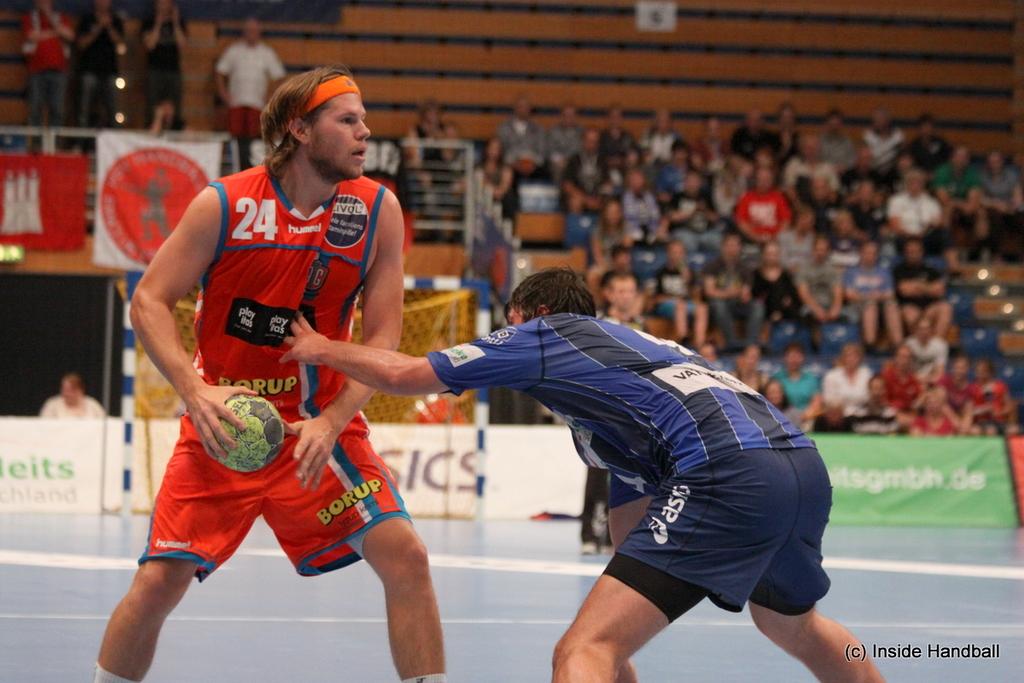What sport are they playing?
Your answer should be very brief. Handball. What number is the man in red?
Your response must be concise. 24. 